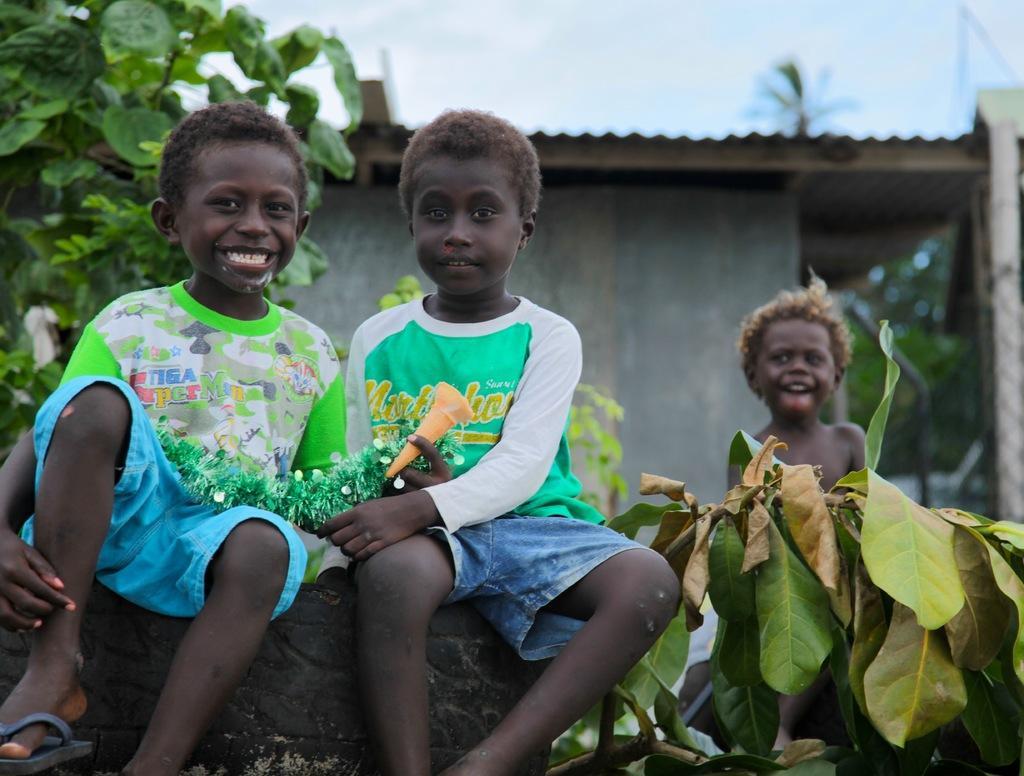Can you describe this image briefly? In the image I can see two boys sitting on the Tyre. They are wearing a T-shirt and short. I can see another boy on the right side. I can see the plants on the top left side. In the background, I can see a house. 